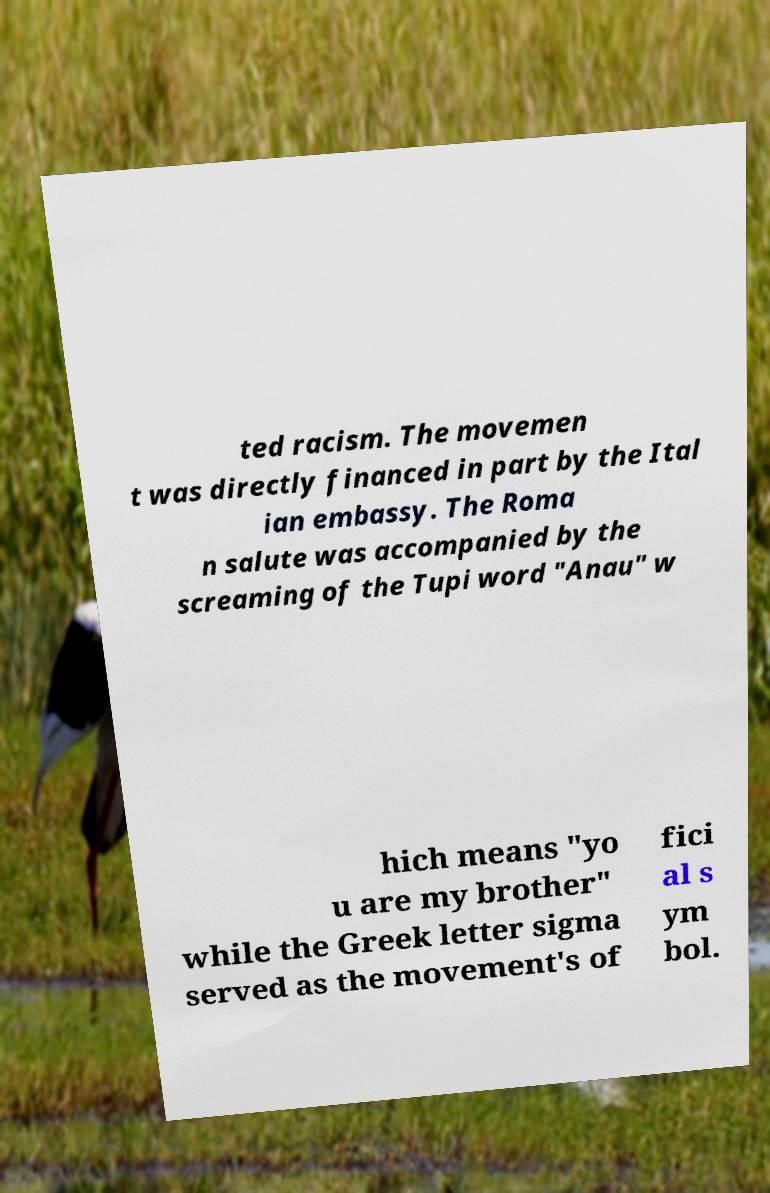Please identify and transcribe the text found in this image. ted racism. The movemen t was directly financed in part by the Ital ian embassy. The Roma n salute was accompanied by the screaming of the Tupi word "Anau" w hich means "yo u are my brother" while the Greek letter sigma served as the movement's of fici al s ym bol. 